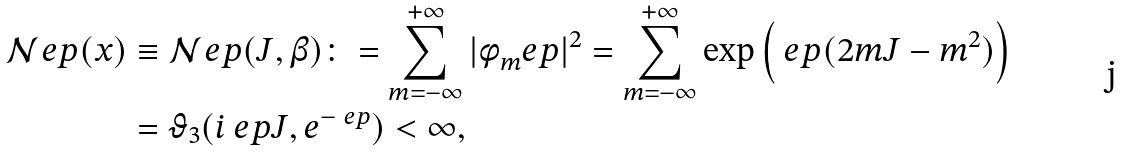Convert formula to latex. <formula><loc_0><loc_0><loc_500><loc_500>\mathcal { N } _ { \ } e p ( x ) & \equiv \mathcal { N } _ { \ } e p ( J , \beta ) \colon = \sum _ { m = - \infty } ^ { + \infty } | \phi _ { m } ^ { \ } e p | ^ { 2 } = \sum _ { m = - \infty } ^ { + \infty } \exp \left ( \ e p ( 2 m J - m ^ { 2 } ) \right ) \\ & = \vartheta _ { 3 } ( i \ e p J , e ^ { - \ e p } ) < \infty ,</formula> 